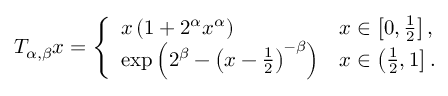<formula> <loc_0><loc_0><loc_500><loc_500>\begin{array} { r } { T _ { \alpha , \beta } x = \left \{ \begin{array} { l l } { x \left ( 1 + 2 ^ { \alpha } x ^ { \alpha } \right ) } & { x \in \left [ 0 , \frac { 1 } { 2 } \right ] , } \\ { \exp \left ( 2 ^ { \beta } - \left ( x - \frac { 1 } { 2 } \right ) ^ { - \beta } \right ) } & { x \in \left ( \frac { 1 } { 2 } , 1 \right ] . } \end{array} } \end{array}</formula> 